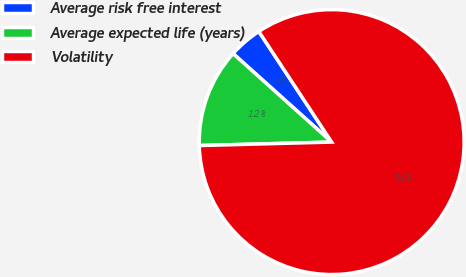<chart> <loc_0><loc_0><loc_500><loc_500><pie_chart><fcel>Average risk free interest<fcel>Average expected life (years)<fcel>Volatility<nl><fcel>4.09%<fcel>12.06%<fcel>83.85%<nl></chart> 